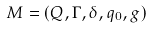Convert formula to latex. <formula><loc_0><loc_0><loc_500><loc_500>M = ( Q , \Gamma , \delta , q _ { 0 } , g )</formula> 